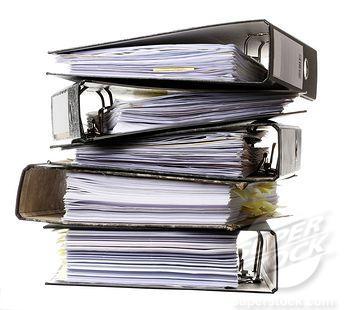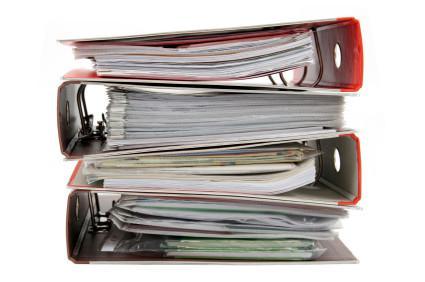The first image is the image on the left, the second image is the image on the right. Evaluate the accuracy of this statement regarding the images: "Both of the images show binders full of papers.". Is it true? Answer yes or no. Yes. The first image is the image on the left, the second image is the image on the right. Examine the images to the left and right. Is the description "All of the binders are stacked with only the ends showing." accurate? Answer yes or no. Yes. 